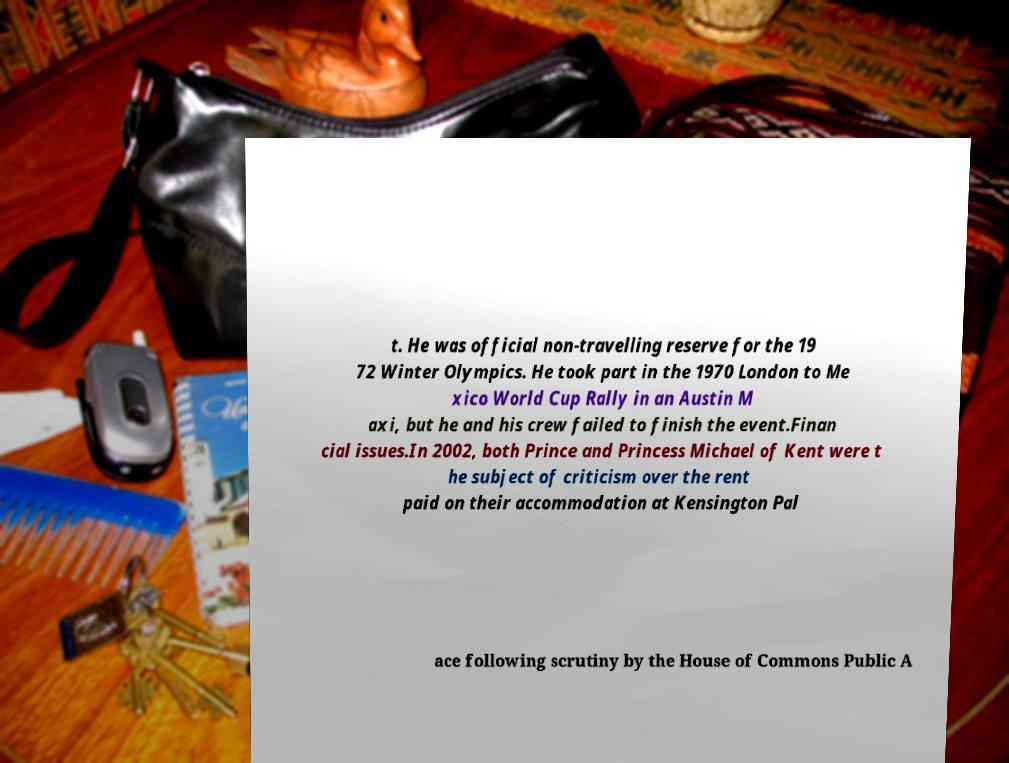Can you accurately transcribe the text from the provided image for me? t. He was official non-travelling reserve for the 19 72 Winter Olympics. He took part in the 1970 London to Me xico World Cup Rally in an Austin M axi, but he and his crew failed to finish the event.Finan cial issues.In 2002, both Prince and Princess Michael of Kent were t he subject of criticism over the rent paid on their accommodation at Kensington Pal ace following scrutiny by the House of Commons Public A 